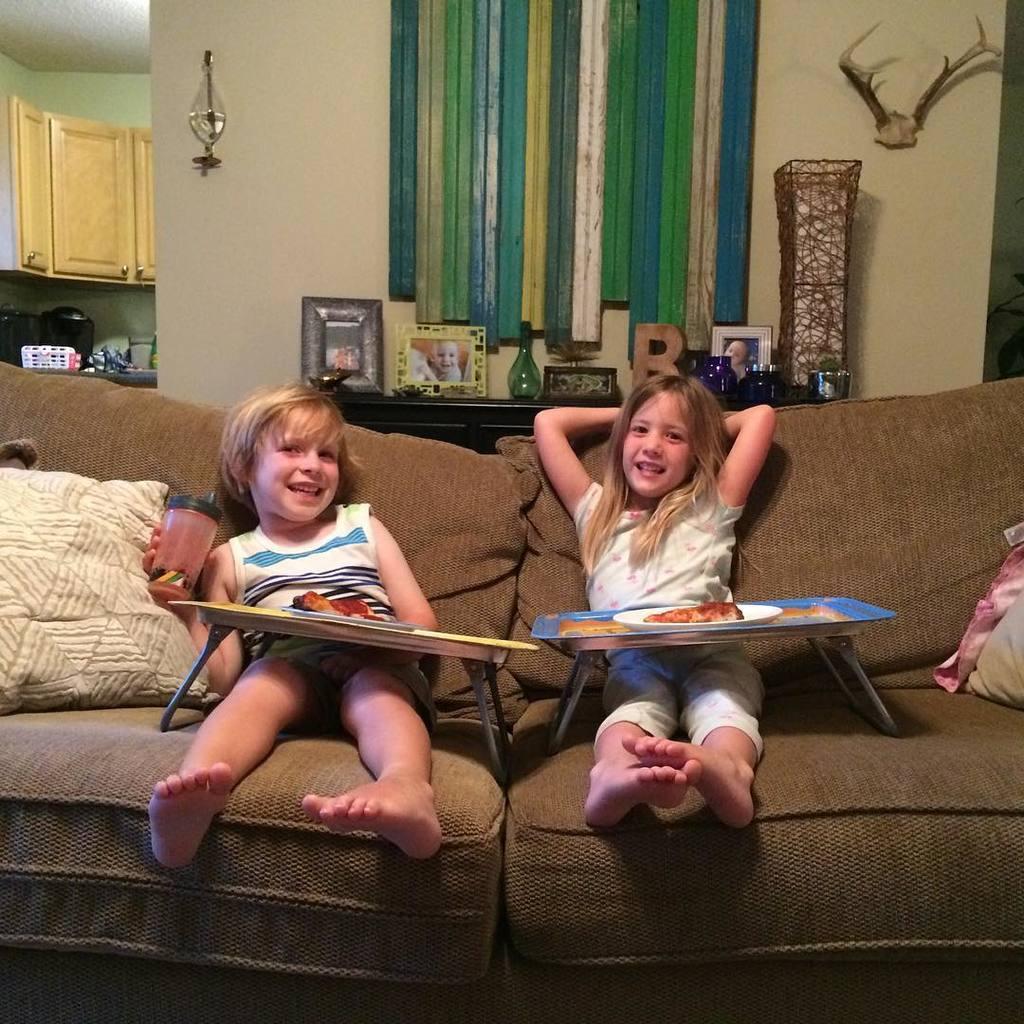How would you summarize this image in a sentence or two? In this picture we can see two kids sitting on the sofa. This is pillow and there is a plate. On the background we can see a wall and these are the frames. And this is cupboard. 